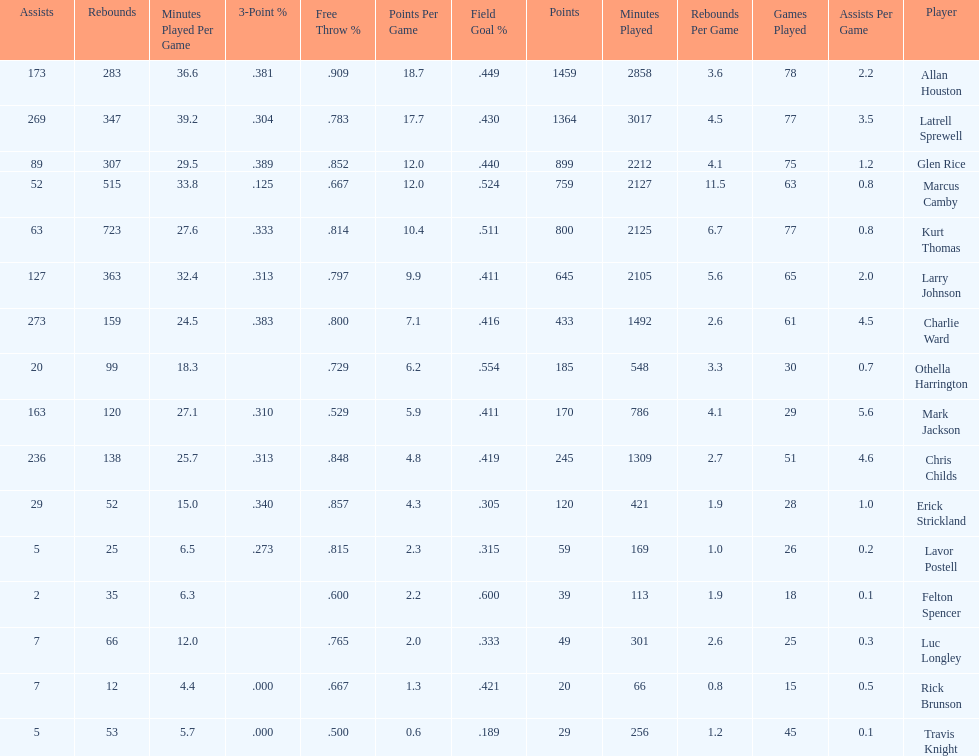How many players had a field goal percentage greater than .500? 4. 